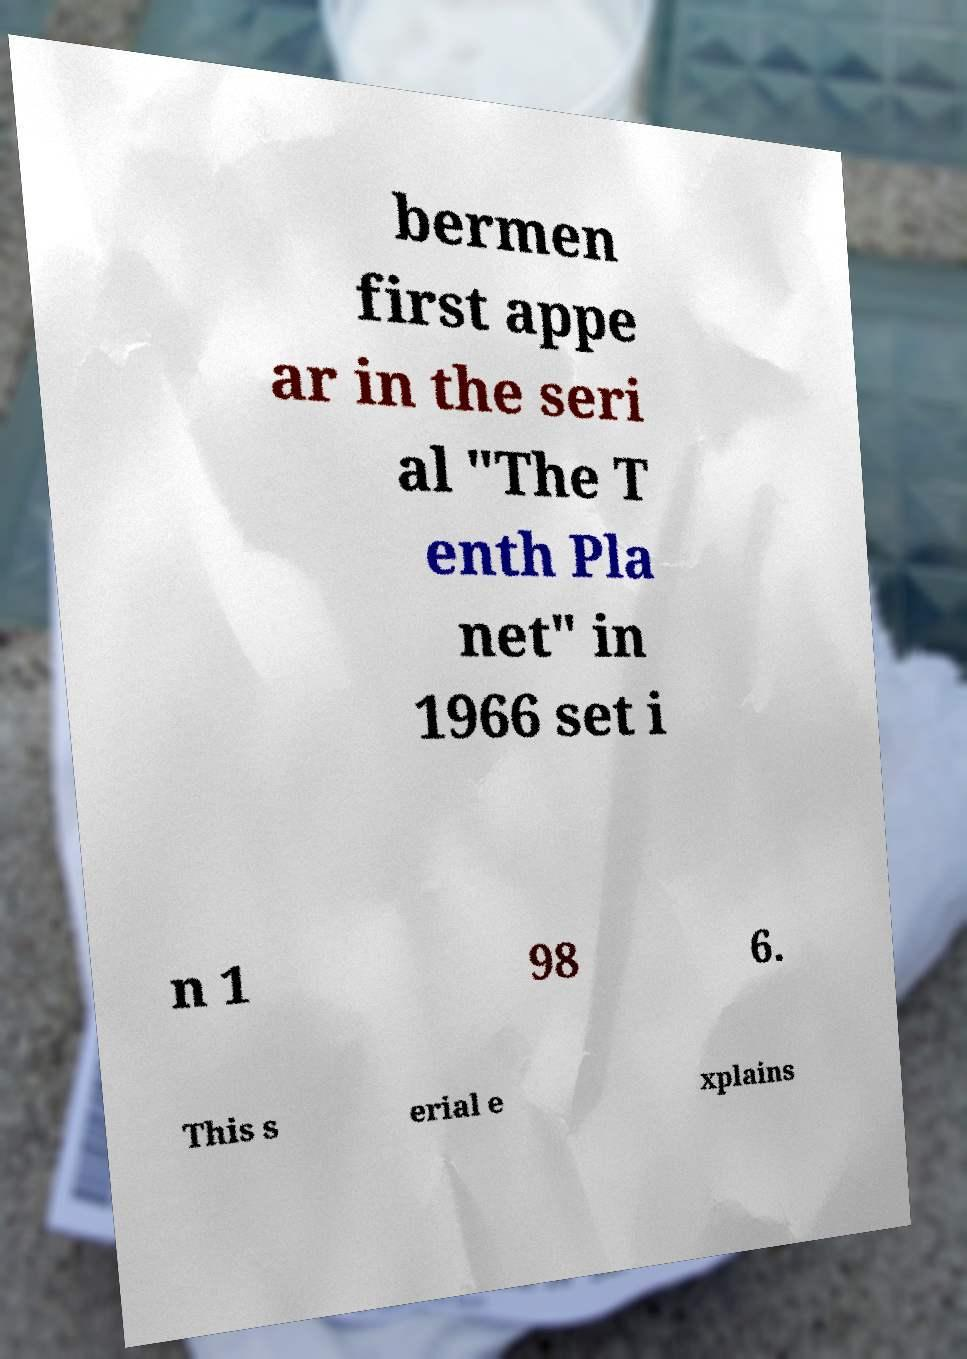Could you extract and type out the text from this image? bermen first appe ar in the seri al "The T enth Pla net" in 1966 set i n 1 98 6. This s erial e xplains 